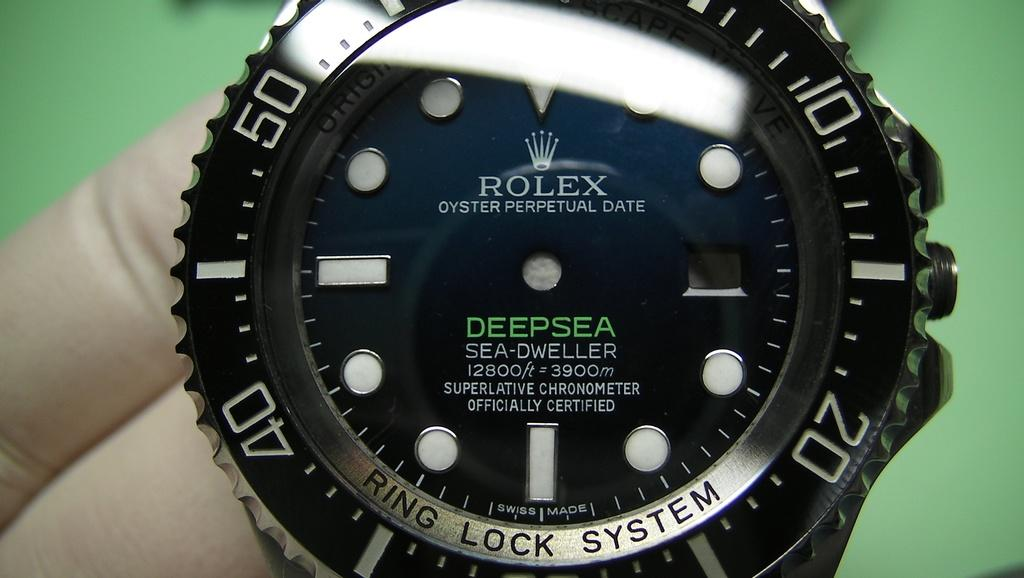<image>
Give a short and clear explanation of the subsequent image. A deep sea Rolex watch is seen close up which has no hands. 